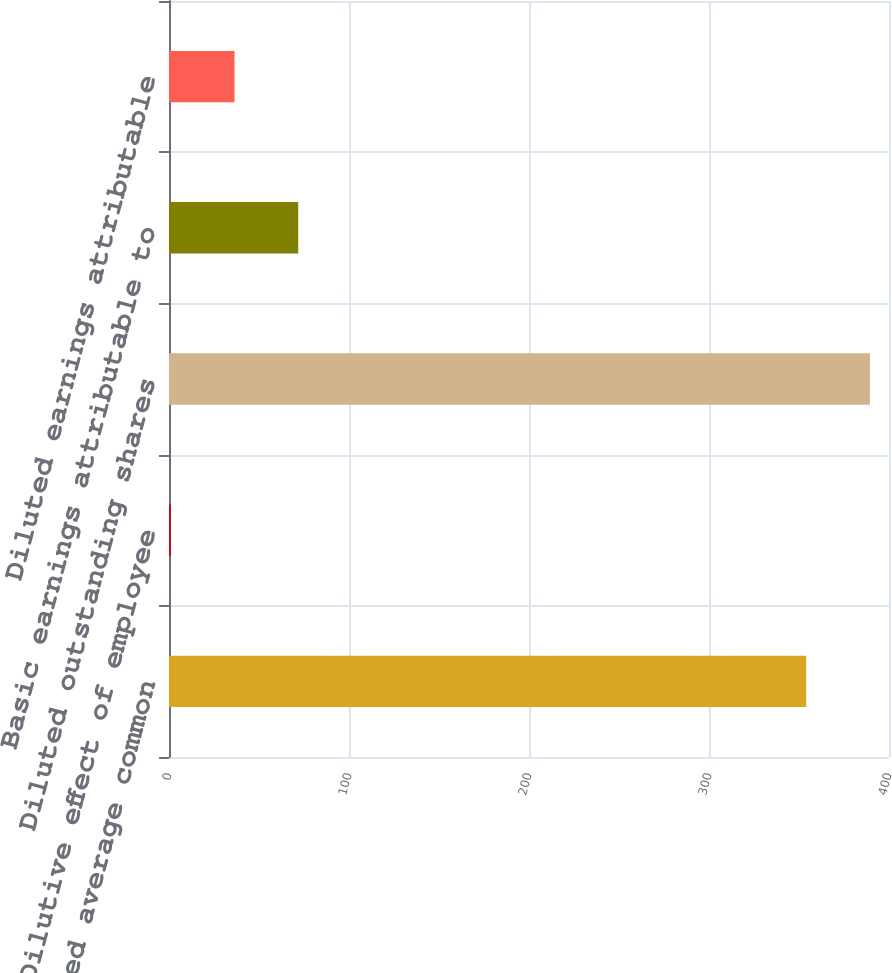Convert chart. <chart><loc_0><loc_0><loc_500><loc_500><bar_chart><fcel>Basic-weighted average common<fcel>Dilutive effect of employee<fcel>Diluted outstanding shares<fcel>Basic earnings attributable to<fcel>Diluted earnings attributable<nl><fcel>354<fcel>1<fcel>389.4<fcel>71.8<fcel>36.4<nl></chart> 